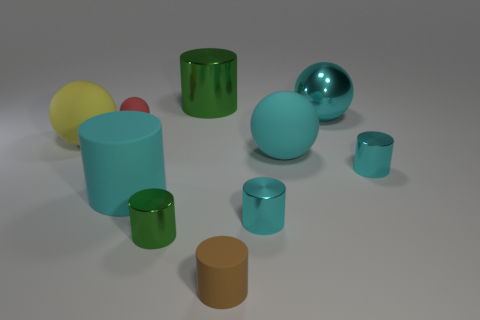Subtract all cyan cylinders. How many were subtracted if there are1cyan cylinders left? 2 Subtract all blue blocks. How many cyan cylinders are left? 3 Subtract all brown cylinders. How many cylinders are left? 5 Subtract all tiny rubber cylinders. How many cylinders are left? 5 Subtract all purple balls. Subtract all yellow blocks. How many balls are left? 4 Subtract all balls. How many objects are left? 6 Add 4 big cylinders. How many big cylinders are left? 6 Add 5 large red cylinders. How many large red cylinders exist? 5 Subtract 1 yellow spheres. How many objects are left? 9 Subtract all cyan objects. Subtract all yellow matte objects. How many objects are left? 4 